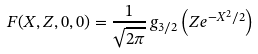Convert formula to latex. <formula><loc_0><loc_0><loc_500><loc_500>F ( X , Z , 0 , 0 ) = \frac { 1 } { \sqrt { 2 \pi } } \, g _ { 3 / 2 } \left ( Z e ^ { - X ^ { 2 } / 2 } \right )</formula> 